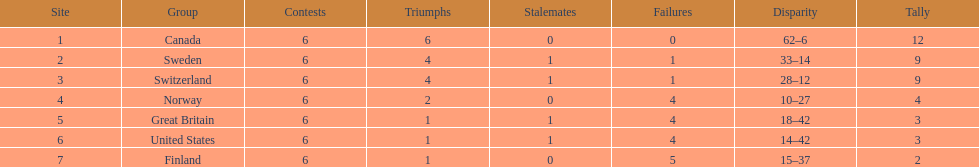What was the number of points won by great britain? 3. 